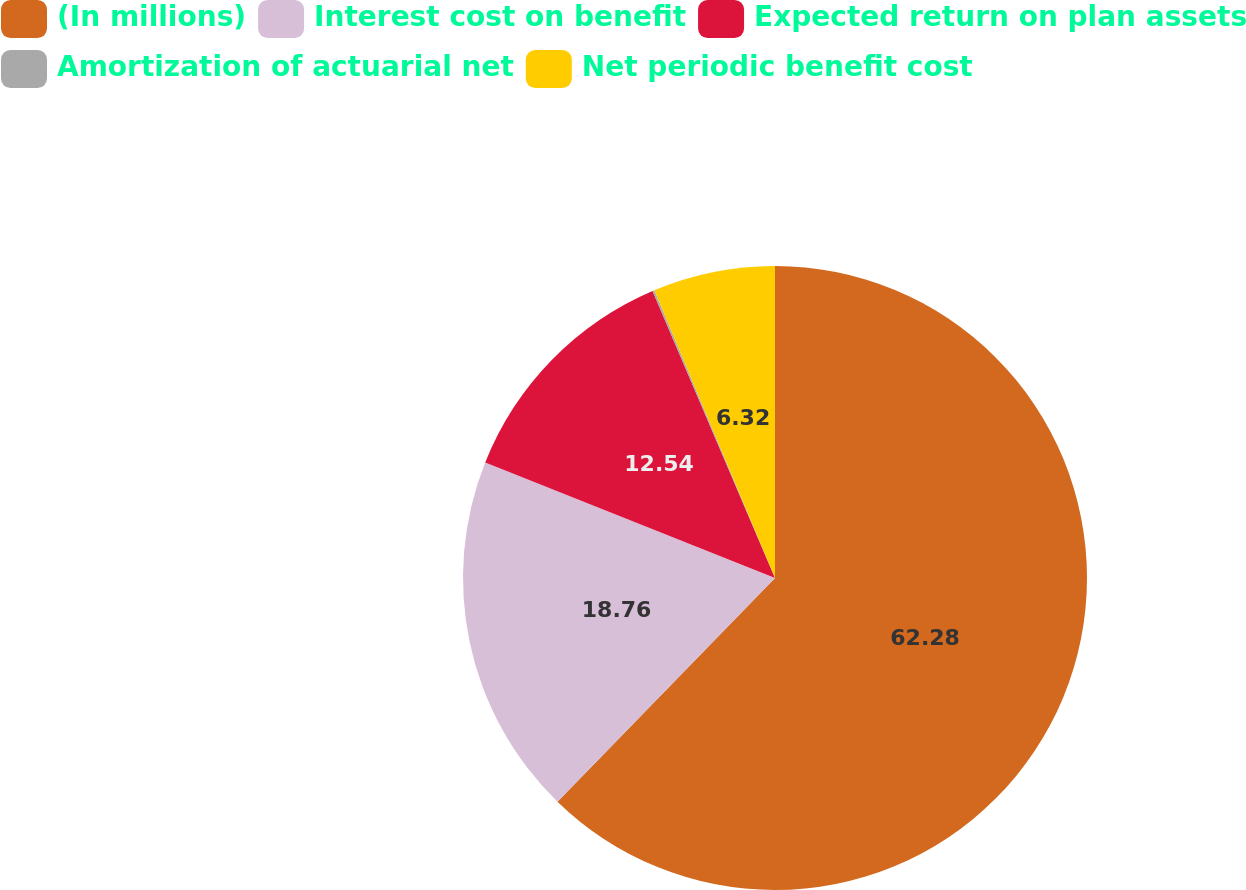Convert chart. <chart><loc_0><loc_0><loc_500><loc_500><pie_chart><fcel>(In millions)<fcel>Interest cost on benefit<fcel>Expected return on plan assets<fcel>Amortization of actuarial net<fcel>Net periodic benefit cost<nl><fcel>62.28%<fcel>18.76%<fcel>12.54%<fcel>0.1%<fcel>6.32%<nl></chart> 